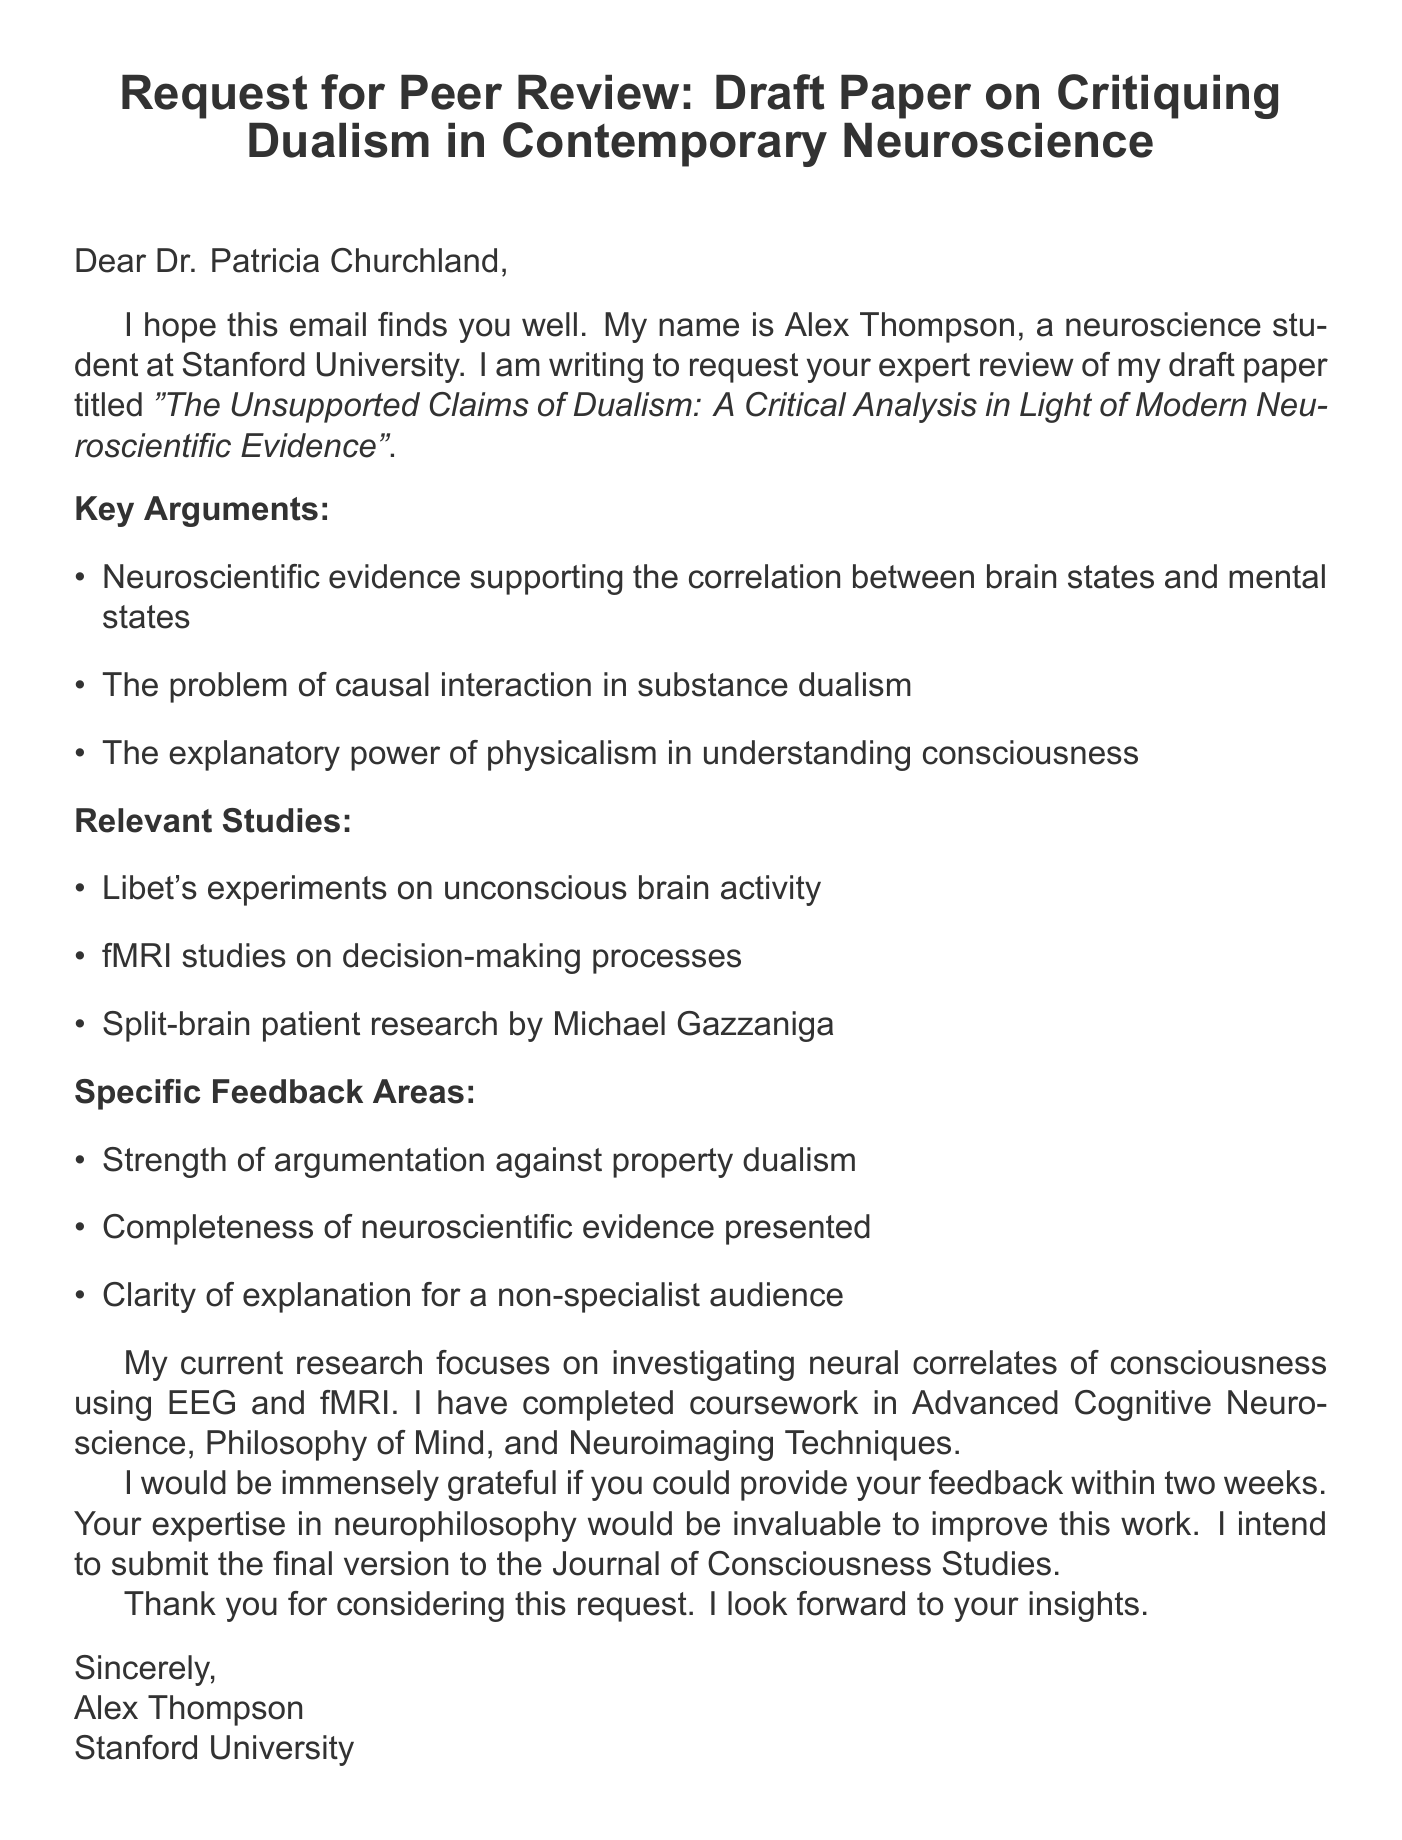What is the title of the paper? The title of the paper is mentioned in the document and provides insight into its subject matter.
Answer: The Unsupported Claims of Dualism: A Critical Analysis in Light of Modern Neuroscientific Evidence Who is the recipient of the email? The recipient is explicitly stated in the address section of the email.
Answer: Dr. Patricia Churchland What is the deadline for providing feedback? The document specifies a timeline for the feedback request.
Answer: Two weeks from today Which studies are cited as relevant? The document lists specific studies that support the key arguments made in the paper.
Answer: Libet's experiments on unconscious brain activity, fMRI studies on decision-making processes, Split-brain patient research by Michael Gazzaniga What specific feedback area focuses on dualism? The document outlines areas where the sender seeks feedback relating directly to dualism.
Answer: Strength of argumentation against property dualism Who is the sender of the email? The sender is clearly identified in the email's introduction, providing context for the request.
Answer: Alex Thompson What is the current research focus of the sender? The sender's research area is specified, providing context for their expertise.
Answer: Investigating neural correlates of consciousness using EEG and fMRI To which journal does the sender intend to submit the final version? The document states the intended journal for submission, indicating the academic target audience.
Answer: Journal of Consciousness Studies 